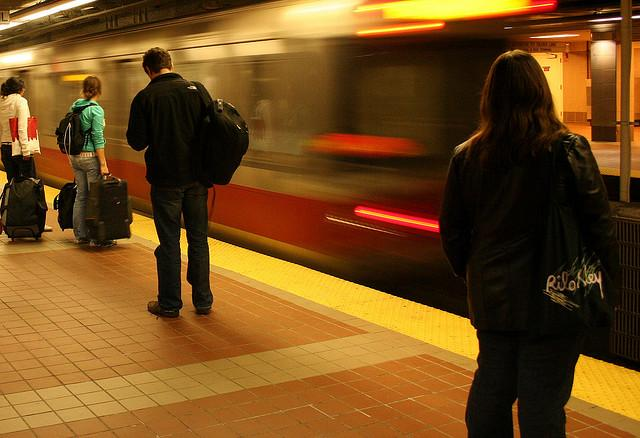What do the people do when the fast moving thing stops?

Choices:
A) exercise
B) cook
C) swim
D) board it board it 